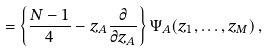Convert formula to latex. <formula><loc_0><loc_0><loc_500><loc_500>= \left \{ \frac { N - 1 } { 4 } - z _ { A } \frac { \partial } { \partial z _ { A } } \right \} \Psi _ { A } ( z _ { 1 } , \dots , z _ { M } ) \, ,</formula> 